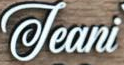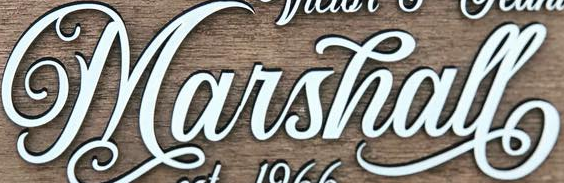What text appears in these images from left to right, separated by a semicolon? Jeani; Marshall 